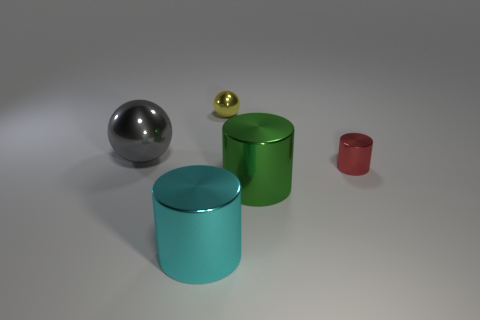Add 2 small metallic cylinders. How many objects exist? 7 Subtract all cylinders. How many objects are left? 2 Subtract all gray objects. Subtract all large green metal cylinders. How many objects are left? 3 Add 1 cyan cylinders. How many cyan cylinders are left? 2 Add 4 cyan metal cylinders. How many cyan metal cylinders exist? 5 Subtract 0 green balls. How many objects are left? 5 